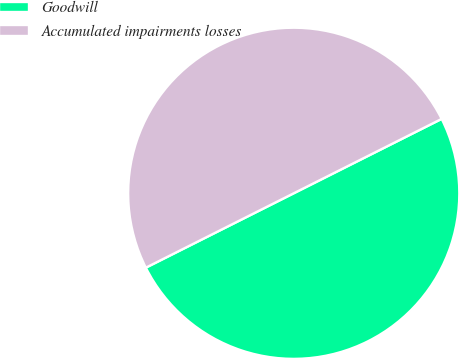Convert chart to OTSL. <chart><loc_0><loc_0><loc_500><loc_500><pie_chart><fcel>Goodwill<fcel>Accumulated impairments losses<nl><fcel>50.0%<fcel>50.0%<nl></chart> 